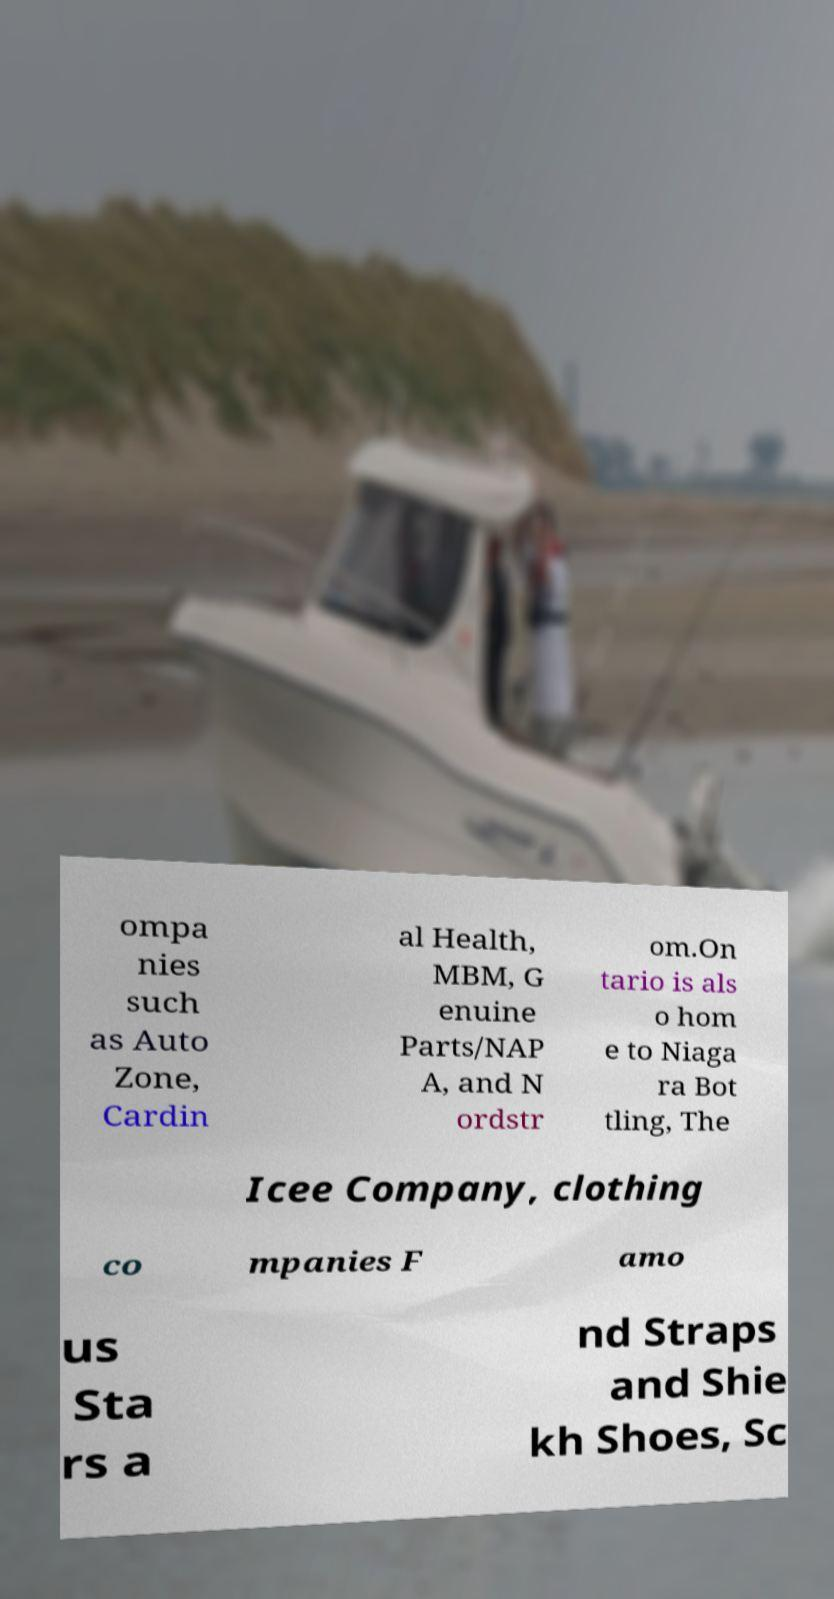I need the written content from this picture converted into text. Can you do that? ompa nies such as Auto Zone, Cardin al Health, MBM, G enuine Parts/NAP A, and N ordstr om.On tario is als o hom e to Niaga ra Bot tling, The Icee Company, clothing co mpanies F amo us Sta rs a nd Straps and Shie kh Shoes, Sc 